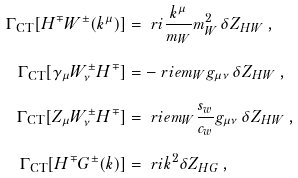Convert formula to latex. <formula><loc_0><loc_0><loc_500><loc_500>\Gamma _ { \text {CT} } [ H ^ { \mp } W ^ { \pm } ( k ^ { \mu } ) ] & = \ r i \frac { k ^ { \mu } } { m _ { W } } m _ { W } ^ { 2 } \, \delta Z _ { H W } \, , \\ \Gamma _ { \text {CT} } [ \gamma _ { \mu } W ^ { \pm } _ { \nu } H ^ { \mp } ] & = - \ r i e m _ { W } g _ { \mu \nu } \, \delta Z _ { H W } \, , \\ \Gamma _ { \text {CT} } [ Z _ { \mu } W ^ { \pm } _ { \nu } H ^ { \mp } ] & = \ r i e m _ { W } \frac { s _ { w } } { c _ { w } } g _ { \mu \nu } \, \delta Z _ { H W } \, , \\ \Gamma _ { \text {CT} } [ H ^ { \mp } G ^ { \pm } ( k ) ] & = \ r i k ^ { 2 } \delta Z _ { H G } \, ,</formula> 